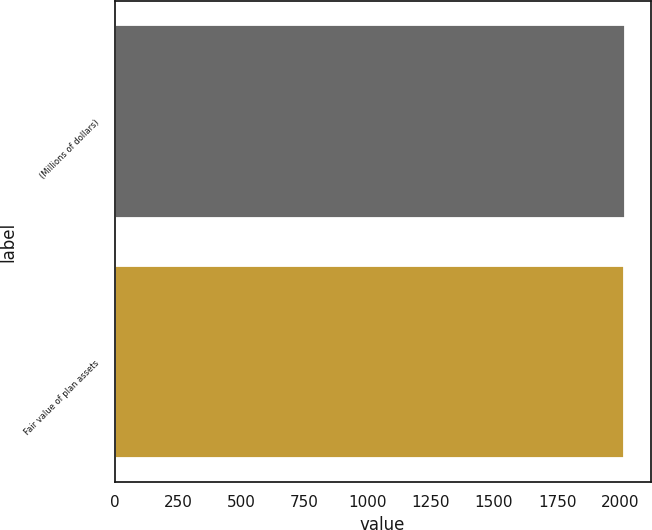<chart> <loc_0><loc_0><loc_500><loc_500><bar_chart><fcel>(Millions of dollars)<fcel>Fair value of plan assets<nl><fcel>2018<fcel>2012<nl></chart> 